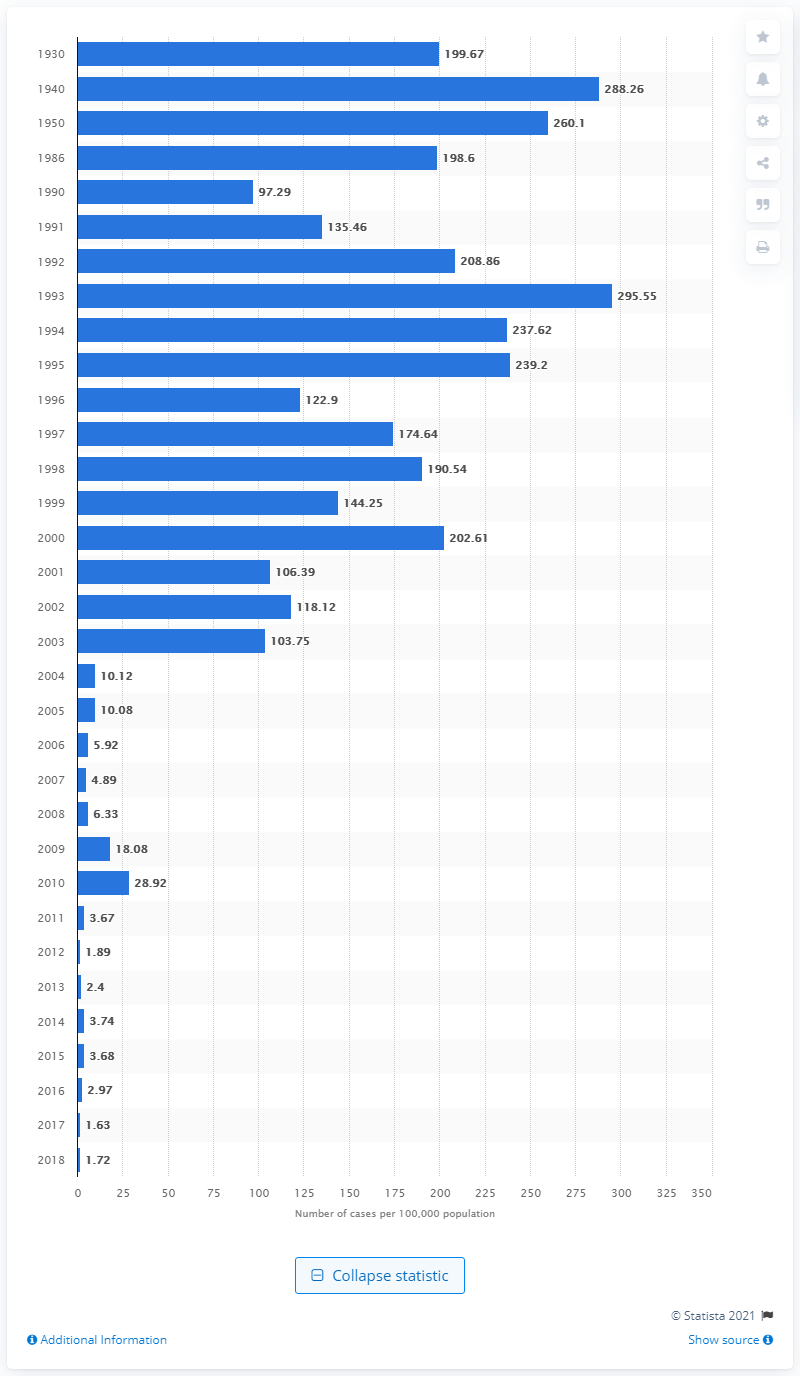Outline some significant characteristics in this image. In Canada in 1930, the reported rate of chickenpox per 100,000 people was 199.67. In 2018, there were 1.72 reported cases of chickenpox in Canada per 100,000 population. In 2018, the chickenpox rate decreased to 1.72 per 100,000 people. 